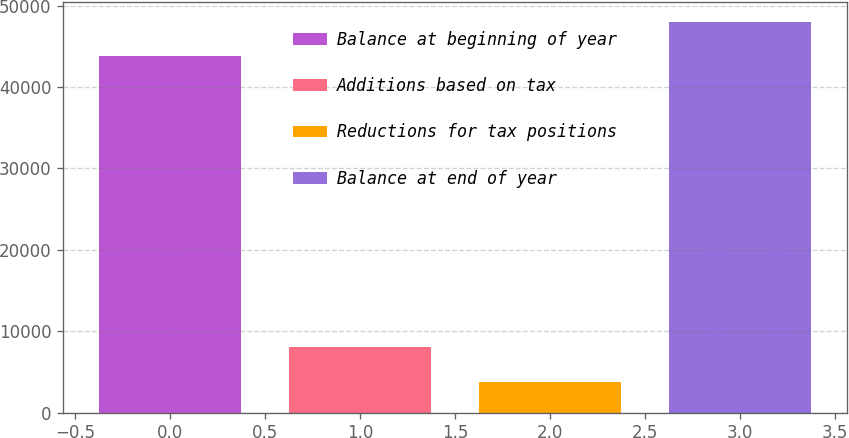Convert chart to OTSL. <chart><loc_0><loc_0><loc_500><loc_500><bar_chart><fcel>Balance at beginning of year<fcel>Additions based on tax<fcel>Reductions for tax positions<fcel>Balance at end of year<nl><fcel>43796<fcel>8020.4<fcel>3800<fcel>48016.4<nl></chart> 